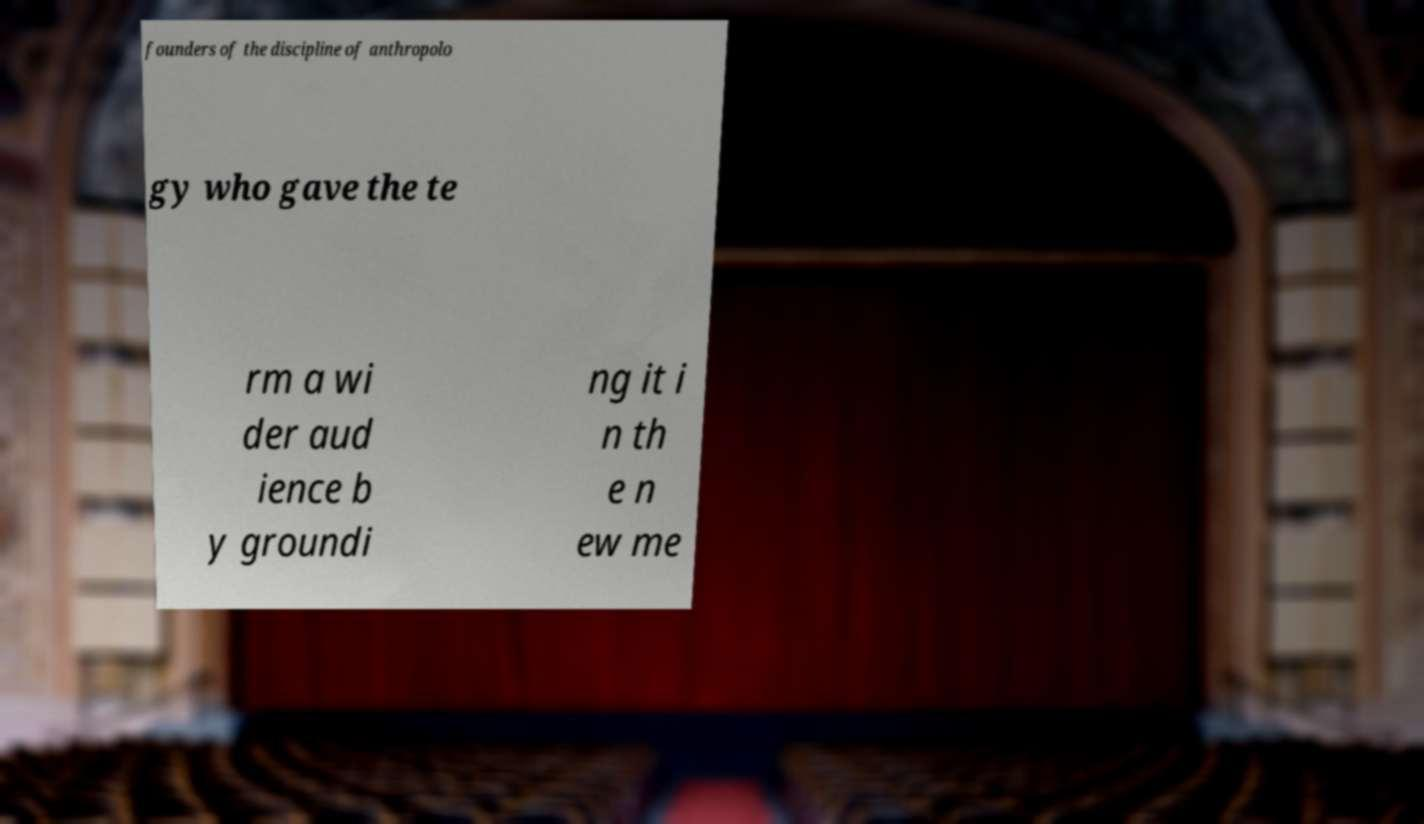Please read and relay the text visible in this image. What does it say? founders of the discipline of anthropolo gy who gave the te rm a wi der aud ience b y groundi ng it i n th e n ew me 